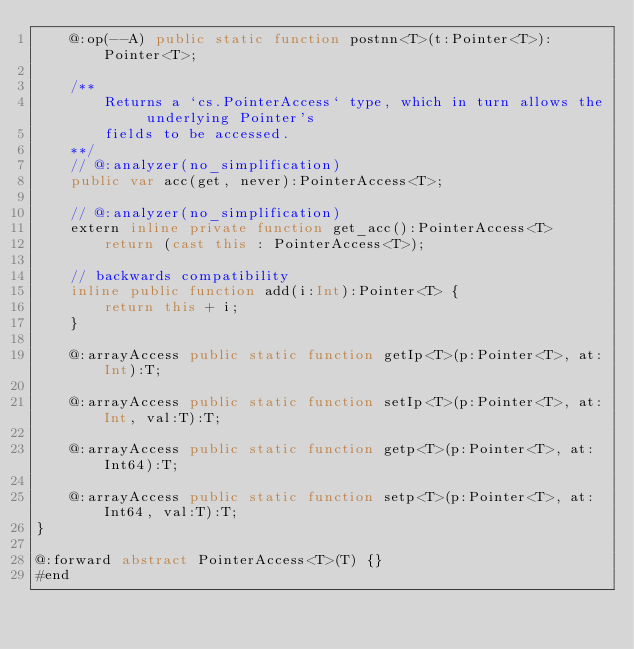<code> <loc_0><loc_0><loc_500><loc_500><_Haxe_>	@:op(--A) public static function postnn<T>(t:Pointer<T>):Pointer<T>;

	/**
		Returns a `cs.PointerAccess` type, which in turn allows the underlying Pointer's
		fields to be accessed.
	**/
	// @:analyzer(no_simplification)
	public var acc(get, never):PointerAccess<T>;

	// @:analyzer(no_simplification)
	extern inline private function get_acc():PointerAccess<T>
		return (cast this : PointerAccess<T>);

	// backwards compatibility
	inline public function add(i:Int):Pointer<T> {
		return this + i;
	}

	@:arrayAccess public static function getIp<T>(p:Pointer<T>, at:Int):T;

	@:arrayAccess public static function setIp<T>(p:Pointer<T>, at:Int, val:T):T;

	@:arrayAccess public static function getp<T>(p:Pointer<T>, at:Int64):T;

	@:arrayAccess public static function setp<T>(p:Pointer<T>, at:Int64, val:T):T;
}

@:forward abstract PointerAccess<T>(T) {}
#end
</code> 